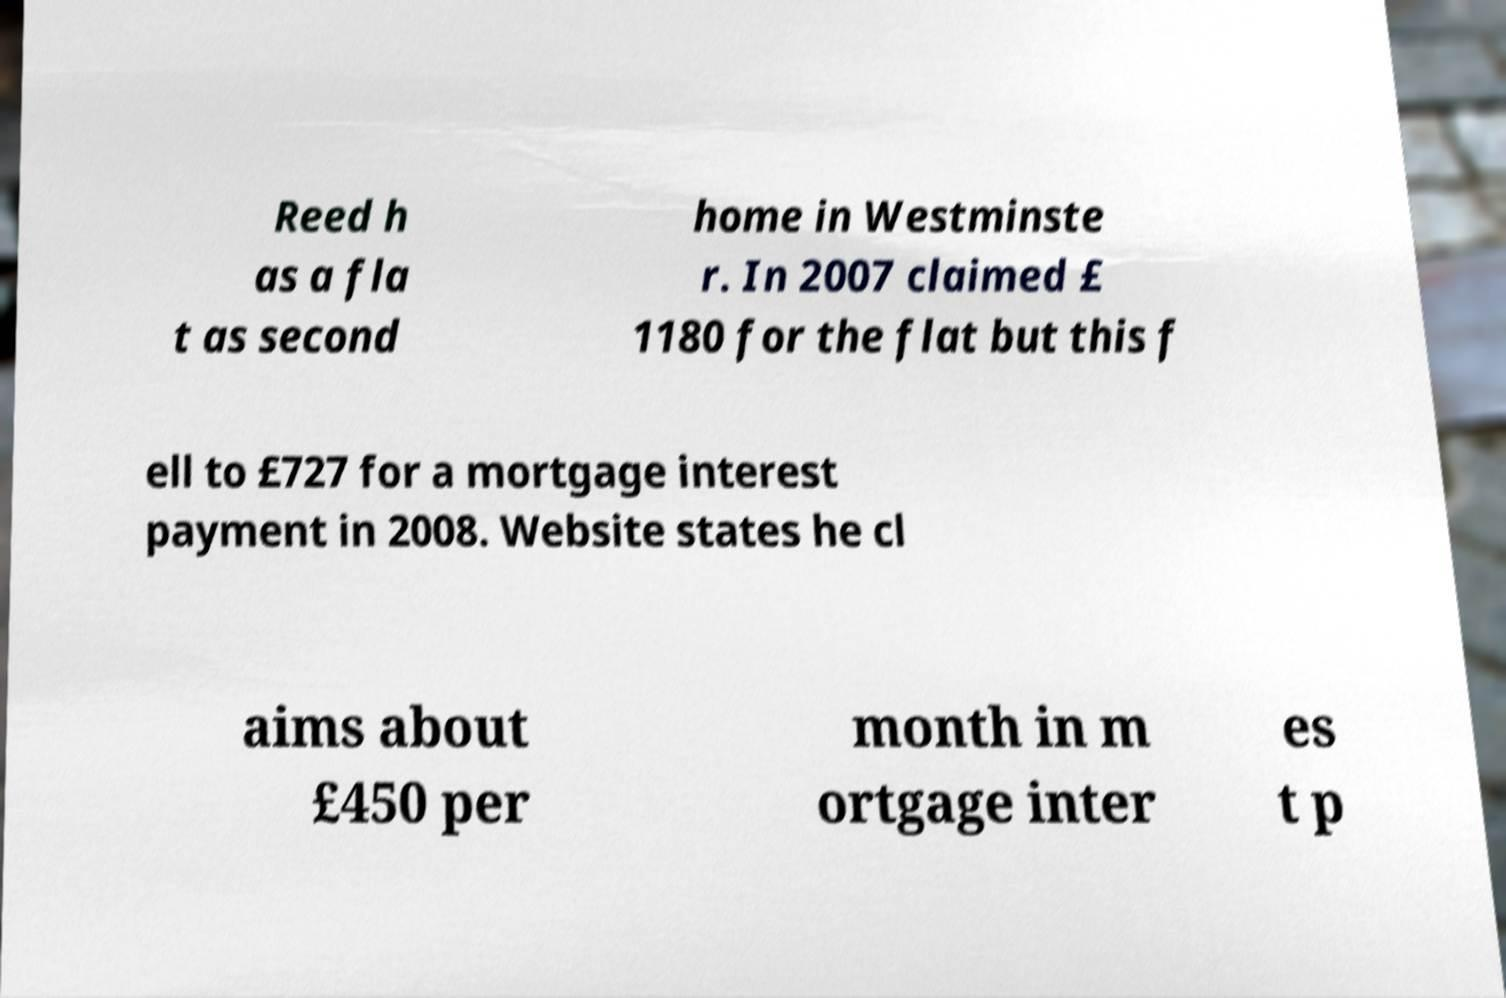Please identify and transcribe the text found in this image. Reed h as a fla t as second home in Westminste r. In 2007 claimed £ 1180 for the flat but this f ell to £727 for a mortgage interest payment in 2008. Website states he cl aims about £450 per month in m ortgage inter es t p 